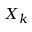<formula> <loc_0><loc_0><loc_500><loc_500>X _ { k }</formula> 